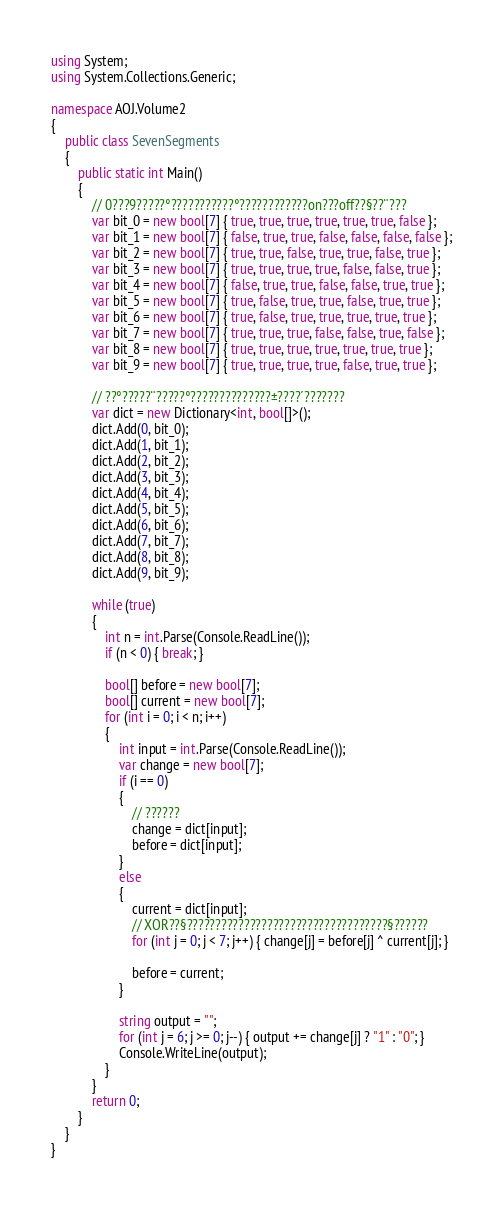Convert code to text. <code><loc_0><loc_0><loc_500><loc_500><_C#_>using System;
using System.Collections.Generic;

namespace AOJ.Volume2
{
    public class SevenSegments
    {
        public static int Main()
        {
            // 0???9?????°???????????°????????????on???off??§??¨???
            var bit_0 = new bool[7] { true, true, true, true, true, true, false };
            var bit_1 = new bool[7] { false, true, true, false, false, false, false };
            var bit_2 = new bool[7] { true, true, false, true, true, false, true };
            var bit_3 = new bool[7] { true, true, true, true, false, false, true };
            var bit_4 = new bool[7] { false, true, true, false, false, true, true };
            var bit_5 = new bool[7] { true, false, true, true, false, true, true };
            var bit_6 = new bool[7] { true, false, true, true, true, true, true };
            var bit_7 = new bool[7] { true, true, true, false, false, true, false };
            var bit_8 = new bool[7] { true, true, true, true, true, true, true };
            var bit_9 = new bool[7] { true, true, true, true, false, true, true };

            // ??°?????¨?????°??????????????±????´???????
            var dict = new Dictionary<int, bool[]>();
            dict.Add(0, bit_0);
            dict.Add(1, bit_1);
            dict.Add(2, bit_2);
            dict.Add(3, bit_3);
            dict.Add(4, bit_4);
            dict.Add(5, bit_5);
            dict.Add(6, bit_6);
            dict.Add(7, bit_7);
            dict.Add(8, bit_8);
            dict.Add(9, bit_9);

            while (true)
            {
                int n = int.Parse(Console.ReadLine());
                if (n < 0) { break; }

                bool[] before = new bool[7];
                bool[] current = new bool[7];
                for (int i = 0; i < n; i++)
                {
                    int input = int.Parse(Console.ReadLine());
                    var change = new bool[7];
                    if (i == 0)
                    {
                        // ??????
                        change = dict[input];
                        before = dict[input];
                    }
                    else
                    {
                        current = dict[input];
                        // XOR??§???????????????????????????????????§??????
                        for (int j = 0; j < 7; j++) { change[j] = before[j] ^ current[j]; }

                        before = current;
                    }

                    string output = "";
                    for (int j = 6; j >= 0; j--) { output += change[j] ? "1" : "0"; }
                    Console.WriteLine(output);
                }
            }
            return 0;
        }
    }
}</code> 